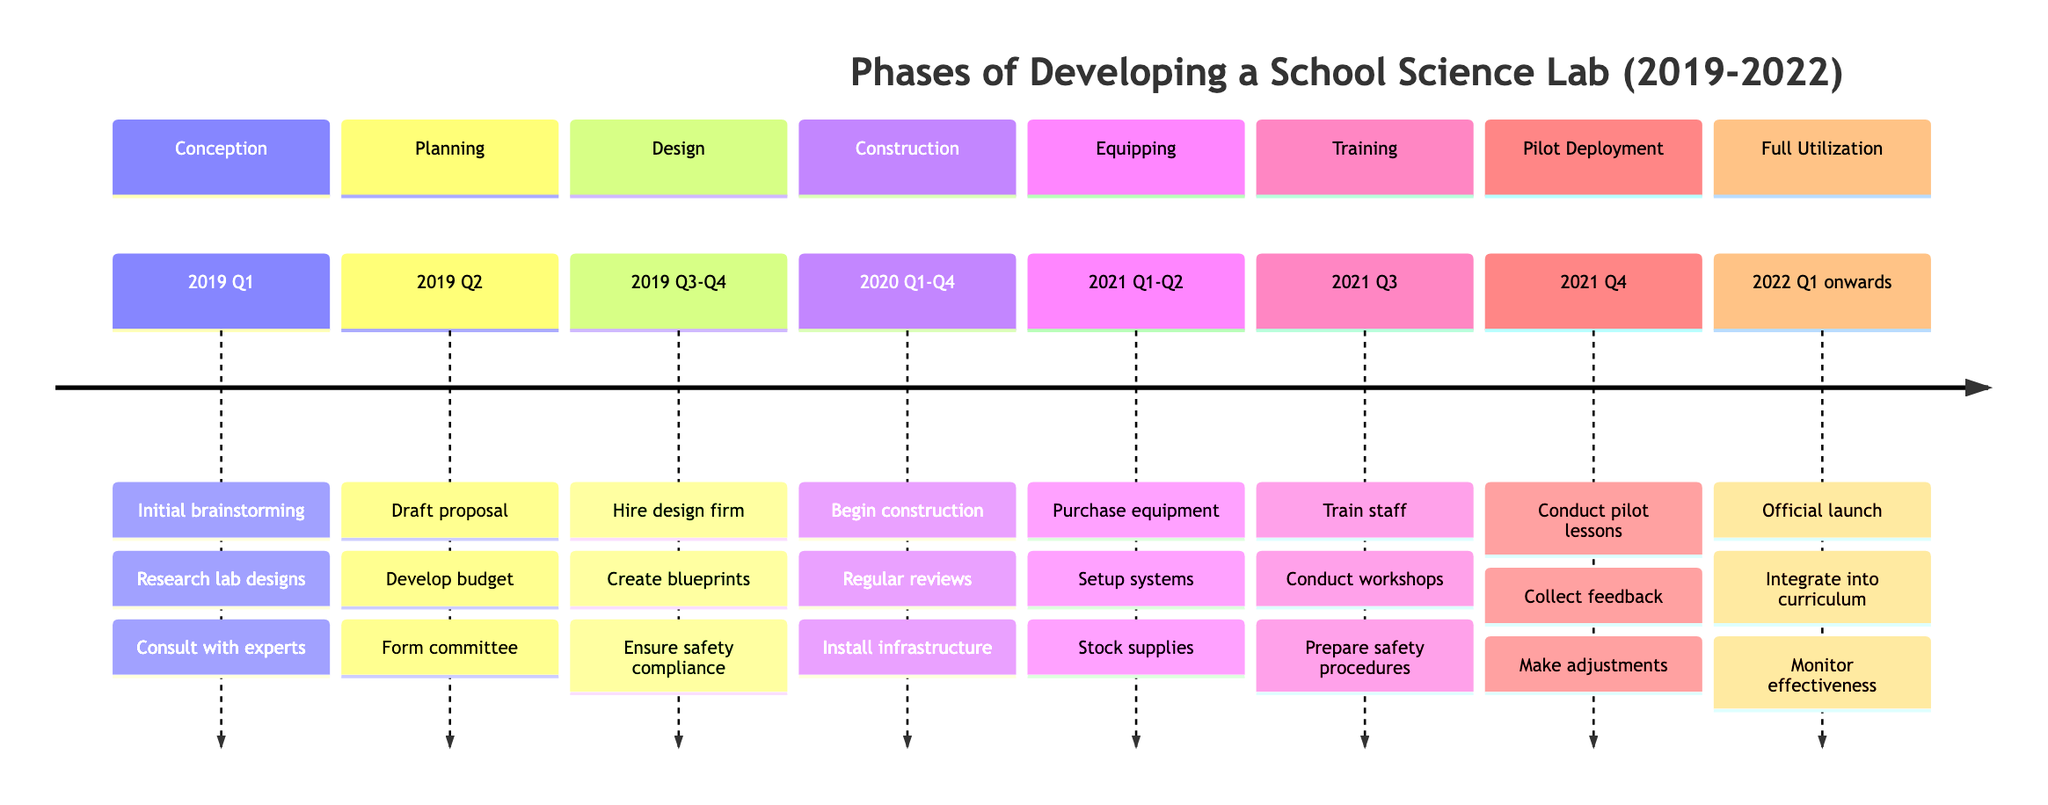What is the duration of the "Equipping" phase? The "Equipping" phase spans from 2021 Q1 to Q2, which means it lasts for two quarters (Q1 and Q2).
Answer: 2 quarters Which entity is involved in the "Construction" phase? The "Construction" phase includes entities such as the Construction Company, Engineering Consultants, and School Project Managers. One of these entities is the Construction Company.
Answer: Construction Company How many phases are there in total? The timeline outlines a total of seven distinct phases from Conception to Full Utilization. Counting each unique phase provides this number.
Answer: 7 What activities are conducted during the "Training" phase? In the "Training" phase, activities include training sessions for teachers and lab staff, professional development workshops, and preparing safety procedures. Listing these activities reveals their scope.
Answer: Training sessions, workshops, safety procedures Which phase comes immediately after "Design"? The phase that follows "Design" in the timeline sequence is "Construction." Identifying the order of the phases helps determine this.
Answer: Construction What activities take place during the "Pilot Deployment" phase? During the "Pilot Deployment" phase, activities are conducted such as pilot lessons and experiments, collecting feedback from students and teachers, and making necessary adjustments. Reviewing these activities gives the answer.
Answer: Conduct pilot lessons, collect feedback, make adjustments What is the start quarter for the "Full Utilization" phase? The "Full Utilization" phase begins in the first quarter of 2022 (2022 Q1), marking the initiation of this phase. Identifying the timeline section provides this information.
Answer: 2022 Q1 How many activities are listed in the "Planning" phase? The "Planning" phase details three specific activities: drafting a proposal for the science lab, developing a budget, and forming a planning committee. Counting these activities reveals their number.
Answer: 3 activities In which quarter does the "Training" phase occur? The "Training" phase occurs in the third quarter of 2021 (2021 Q3), highlighting its specific timing within the overall timeline. Examining the timeline provides this answer.
Answer: 2021 Q3 